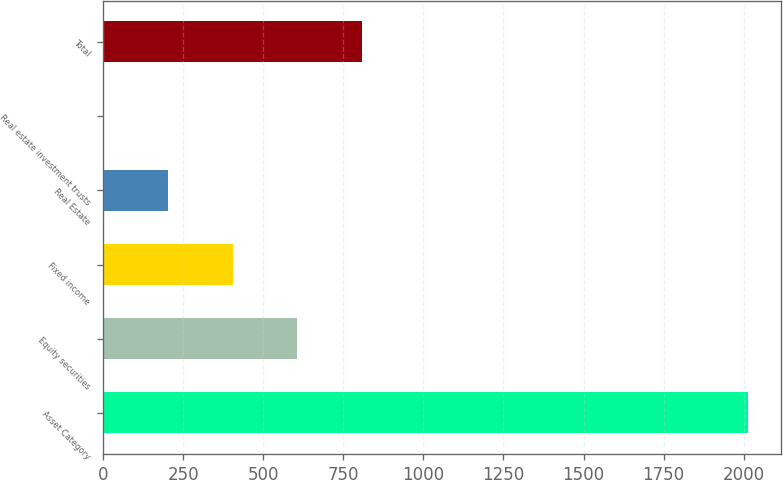Convert chart to OTSL. <chart><loc_0><loc_0><loc_500><loc_500><bar_chart><fcel>Asset Category<fcel>Equity securities<fcel>Fixed income<fcel>Real Estate<fcel>Real estate investment trusts<fcel>Total<nl><fcel>2015<fcel>605.9<fcel>404.6<fcel>203.3<fcel>2<fcel>807.2<nl></chart> 